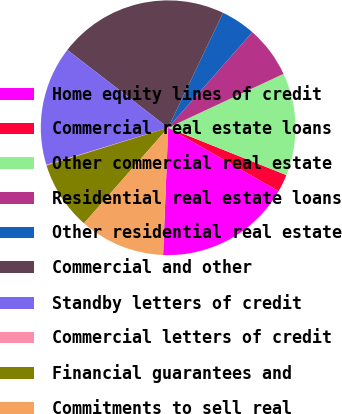Convert chart to OTSL. <chart><loc_0><loc_0><loc_500><loc_500><pie_chart><fcel>Home equity lines of credit<fcel>Commercial real estate loans<fcel>Other commercial real estate<fcel>Residential real estate loans<fcel>Other residential real estate<fcel>Commercial and other<fcel>Standby letters of credit<fcel>Commercial letters of credit<fcel>Financial guarantees and<fcel>Commitments to sell real<nl><fcel>17.33%<fcel>2.24%<fcel>13.02%<fcel>6.55%<fcel>4.4%<fcel>21.63%<fcel>15.17%<fcel>0.09%<fcel>8.71%<fcel>10.86%<nl></chart> 